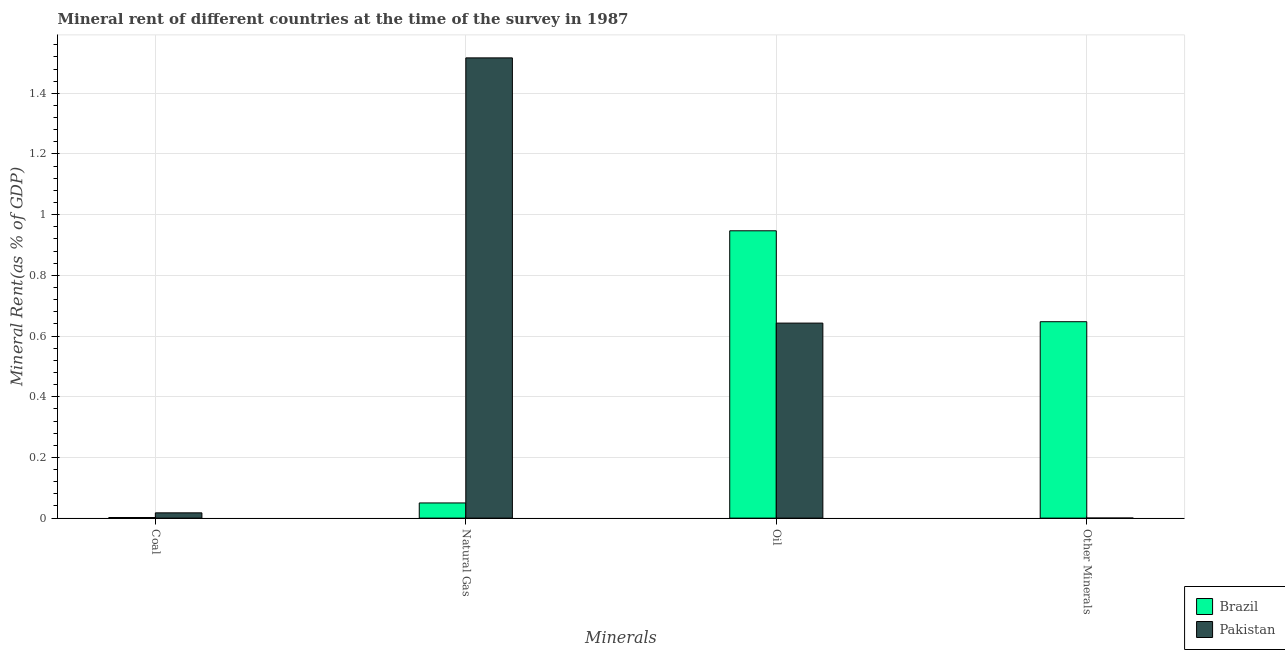How many groups of bars are there?
Ensure brevity in your answer.  4. Are the number of bars per tick equal to the number of legend labels?
Provide a short and direct response. Yes. Are the number of bars on each tick of the X-axis equal?
Your answer should be very brief. Yes. How many bars are there on the 3rd tick from the left?
Keep it short and to the point. 2. How many bars are there on the 4th tick from the right?
Ensure brevity in your answer.  2. What is the label of the 2nd group of bars from the left?
Your response must be concise. Natural Gas. What is the coal rent in Brazil?
Offer a very short reply. 0. Across all countries, what is the maximum natural gas rent?
Give a very brief answer. 1.52. Across all countries, what is the minimum natural gas rent?
Offer a very short reply. 0.05. In which country was the coal rent minimum?
Ensure brevity in your answer.  Brazil. What is the total natural gas rent in the graph?
Provide a short and direct response. 1.57. What is the difference between the natural gas rent in Brazil and that in Pakistan?
Make the answer very short. -1.47. What is the difference between the coal rent in Brazil and the natural gas rent in Pakistan?
Keep it short and to the point. -1.51. What is the average oil rent per country?
Your response must be concise. 0.79. What is the difference between the natural gas rent and  rent of other minerals in Brazil?
Your response must be concise. -0.6. In how many countries, is the natural gas rent greater than 1.12 %?
Offer a very short reply. 1. What is the ratio of the natural gas rent in Pakistan to that in Brazil?
Make the answer very short. 30.33. Is the coal rent in Pakistan less than that in Brazil?
Your answer should be very brief. No. What is the difference between the highest and the second highest natural gas rent?
Give a very brief answer. 1.47. What is the difference between the highest and the lowest coal rent?
Your answer should be compact. 0.02. How many bars are there?
Keep it short and to the point. 8. Are all the bars in the graph horizontal?
Your response must be concise. No. How many countries are there in the graph?
Offer a very short reply. 2. Does the graph contain grids?
Ensure brevity in your answer.  Yes. How many legend labels are there?
Offer a terse response. 2. How are the legend labels stacked?
Offer a terse response. Vertical. What is the title of the graph?
Give a very brief answer. Mineral rent of different countries at the time of the survey in 1987. What is the label or title of the X-axis?
Ensure brevity in your answer.  Minerals. What is the label or title of the Y-axis?
Your answer should be very brief. Mineral Rent(as % of GDP). What is the Mineral Rent(as % of GDP) in Brazil in Coal?
Your response must be concise. 0. What is the Mineral Rent(as % of GDP) in Pakistan in Coal?
Make the answer very short. 0.02. What is the Mineral Rent(as % of GDP) in Brazil in Natural Gas?
Your answer should be compact. 0.05. What is the Mineral Rent(as % of GDP) of Pakistan in Natural Gas?
Offer a terse response. 1.52. What is the Mineral Rent(as % of GDP) in Brazil in Oil?
Offer a very short reply. 0.95. What is the Mineral Rent(as % of GDP) of Pakistan in Oil?
Give a very brief answer. 0.64. What is the Mineral Rent(as % of GDP) in Brazil in Other Minerals?
Provide a short and direct response. 0.65. What is the Mineral Rent(as % of GDP) of Pakistan in Other Minerals?
Offer a terse response. 0. Across all Minerals, what is the maximum Mineral Rent(as % of GDP) of Brazil?
Give a very brief answer. 0.95. Across all Minerals, what is the maximum Mineral Rent(as % of GDP) of Pakistan?
Your answer should be very brief. 1.52. Across all Minerals, what is the minimum Mineral Rent(as % of GDP) of Brazil?
Your answer should be compact. 0. Across all Minerals, what is the minimum Mineral Rent(as % of GDP) in Pakistan?
Your answer should be compact. 0. What is the total Mineral Rent(as % of GDP) of Brazil in the graph?
Offer a terse response. 1.65. What is the total Mineral Rent(as % of GDP) in Pakistan in the graph?
Give a very brief answer. 2.18. What is the difference between the Mineral Rent(as % of GDP) in Brazil in Coal and that in Natural Gas?
Provide a succinct answer. -0.05. What is the difference between the Mineral Rent(as % of GDP) in Pakistan in Coal and that in Natural Gas?
Provide a succinct answer. -1.5. What is the difference between the Mineral Rent(as % of GDP) of Brazil in Coal and that in Oil?
Your answer should be compact. -0.94. What is the difference between the Mineral Rent(as % of GDP) in Pakistan in Coal and that in Oil?
Offer a very short reply. -0.63. What is the difference between the Mineral Rent(as % of GDP) of Brazil in Coal and that in Other Minerals?
Offer a very short reply. -0.65. What is the difference between the Mineral Rent(as % of GDP) in Pakistan in Coal and that in Other Minerals?
Your answer should be very brief. 0.02. What is the difference between the Mineral Rent(as % of GDP) of Brazil in Natural Gas and that in Oil?
Your answer should be very brief. -0.9. What is the difference between the Mineral Rent(as % of GDP) of Pakistan in Natural Gas and that in Oil?
Offer a terse response. 0.87. What is the difference between the Mineral Rent(as % of GDP) of Brazil in Natural Gas and that in Other Minerals?
Provide a succinct answer. -0.6. What is the difference between the Mineral Rent(as % of GDP) in Pakistan in Natural Gas and that in Other Minerals?
Give a very brief answer. 1.52. What is the difference between the Mineral Rent(as % of GDP) of Brazil in Oil and that in Other Minerals?
Give a very brief answer. 0.3. What is the difference between the Mineral Rent(as % of GDP) of Pakistan in Oil and that in Other Minerals?
Ensure brevity in your answer.  0.64. What is the difference between the Mineral Rent(as % of GDP) of Brazil in Coal and the Mineral Rent(as % of GDP) of Pakistan in Natural Gas?
Ensure brevity in your answer.  -1.51. What is the difference between the Mineral Rent(as % of GDP) in Brazil in Coal and the Mineral Rent(as % of GDP) in Pakistan in Oil?
Provide a short and direct response. -0.64. What is the difference between the Mineral Rent(as % of GDP) in Brazil in Coal and the Mineral Rent(as % of GDP) in Pakistan in Other Minerals?
Provide a short and direct response. 0. What is the difference between the Mineral Rent(as % of GDP) of Brazil in Natural Gas and the Mineral Rent(as % of GDP) of Pakistan in Oil?
Your answer should be very brief. -0.59. What is the difference between the Mineral Rent(as % of GDP) of Brazil in Natural Gas and the Mineral Rent(as % of GDP) of Pakistan in Other Minerals?
Offer a terse response. 0.05. What is the difference between the Mineral Rent(as % of GDP) of Brazil in Oil and the Mineral Rent(as % of GDP) of Pakistan in Other Minerals?
Your response must be concise. 0.95. What is the average Mineral Rent(as % of GDP) of Brazil per Minerals?
Your answer should be compact. 0.41. What is the average Mineral Rent(as % of GDP) in Pakistan per Minerals?
Provide a succinct answer. 0.54. What is the difference between the Mineral Rent(as % of GDP) of Brazil and Mineral Rent(as % of GDP) of Pakistan in Coal?
Your response must be concise. -0.02. What is the difference between the Mineral Rent(as % of GDP) of Brazil and Mineral Rent(as % of GDP) of Pakistan in Natural Gas?
Offer a terse response. -1.47. What is the difference between the Mineral Rent(as % of GDP) of Brazil and Mineral Rent(as % of GDP) of Pakistan in Oil?
Keep it short and to the point. 0.3. What is the difference between the Mineral Rent(as % of GDP) in Brazil and Mineral Rent(as % of GDP) in Pakistan in Other Minerals?
Provide a succinct answer. 0.65. What is the ratio of the Mineral Rent(as % of GDP) of Brazil in Coal to that in Natural Gas?
Offer a terse response. 0.04. What is the ratio of the Mineral Rent(as % of GDP) in Pakistan in Coal to that in Natural Gas?
Keep it short and to the point. 0.01. What is the ratio of the Mineral Rent(as % of GDP) of Brazil in Coal to that in Oil?
Give a very brief answer. 0. What is the ratio of the Mineral Rent(as % of GDP) of Pakistan in Coal to that in Oil?
Give a very brief answer. 0.03. What is the ratio of the Mineral Rent(as % of GDP) of Brazil in Coal to that in Other Minerals?
Your answer should be very brief. 0. What is the ratio of the Mineral Rent(as % of GDP) of Pakistan in Coal to that in Other Minerals?
Ensure brevity in your answer.  93.66. What is the ratio of the Mineral Rent(as % of GDP) of Brazil in Natural Gas to that in Oil?
Your answer should be very brief. 0.05. What is the ratio of the Mineral Rent(as % of GDP) in Pakistan in Natural Gas to that in Oil?
Keep it short and to the point. 2.36. What is the ratio of the Mineral Rent(as % of GDP) in Brazil in Natural Gas to that in Other Minerals?
Provide a succinct answer. 0.08. What is the ratio of the Mineral Rent(as % of GDP) of Pakistan in Natural Gas to that in Other Minerals?
Your answer should be very brief. 8177.24. What is the ratio of the Mineral Rent(as % of GDP) of Brazil in Oil to that in Other Minerals?
Provide a short and direct response. 1.46. What is the ratio of the Mineral Rent(as % of GDP) in Pakistan in Oil to that in Other Minerals?
Ensure brevity in your answer.  3464.94. What is the difference between the highest and the second highest Mineral Rent(as % of GDP) in Brazil?
Provide a succinct answer. 0.3. What is the difference between the highest and the second highest Mineral Rent(as % of GDP) of Pakistan?
Your response must be concise. 0.87. What is the difference between the highest and the lowest Mineral Rent(as % of GDP) in Brazil?
Ensure brevity in your answer.  0.94. What is the difference between the highest and the lowest Mineral Rent(as % of GDP) in Pakistan?
Make the answer very short. 1.52. 